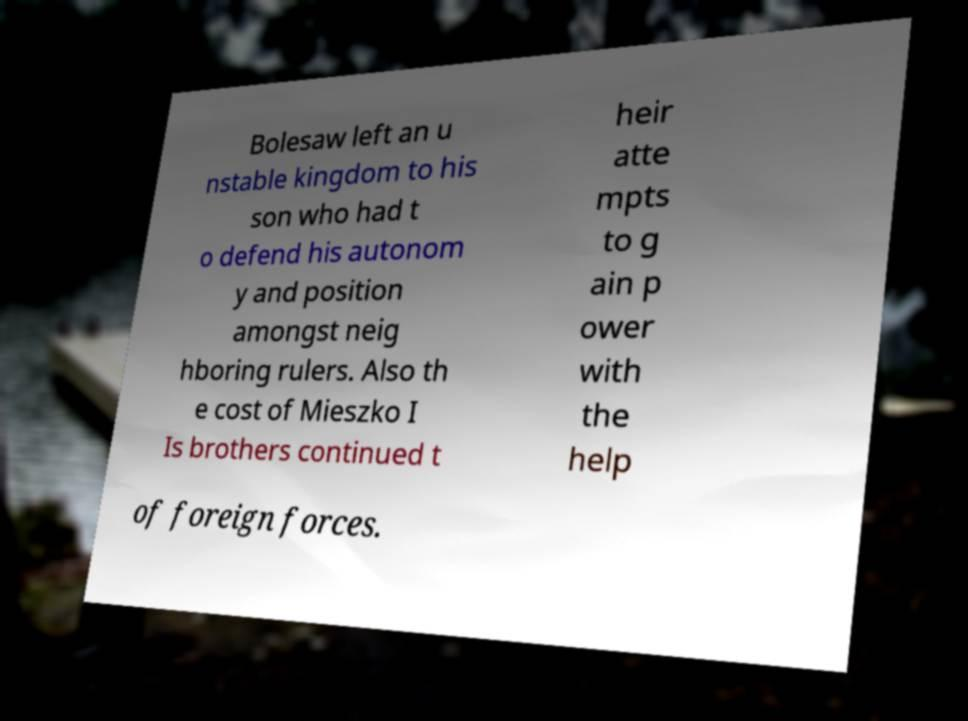What messages or text are displayed in this image? I need them in a readable, typed format. Bolesaw left an u nstable kingdom to his son who had t o defend his autonom y and position amongst neig hboring rulers. Also th e cost of Mieszko I Is brothers continued t heir atte mpts to g ain p ower with the help of foreign forces. 